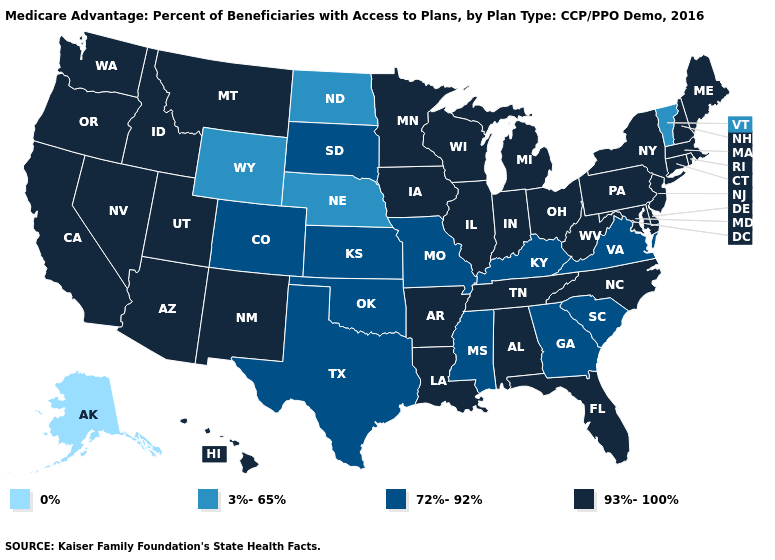Name the states that have a value in the range 93%-100%?
Quick response, please. California, Connecticut, Delaware, Florida, Hawaii, Iowa, Idaho, Illinois, Indiana, Louisiana, Massachusetts, Maryland, Maine, Michigan, Minnesota, Montana, North Carolina, New Hampshire, New Jersey, New Mexico, Nevada, New York, Ohio, Oregon, Pennsylvania, Rhode Island, Tennessee, Utah, Washington, Wisconsin, West Virginia, Alabama, Arkansas, Arizona. Does Nebraska have the highest value in the MidWest?
Quick response, please. No. Which states hav the highest value in the Northeast?
Be succinct. Connecticut, Massachusetts, Maine, New Hampshire, New Jersey, New York, Pennsylvania, Rhode Island. Does New Mexico have the lowest value in the USA?
Write a very short answer. No. Name the states that have a value in the range 93%-100%?
Be succinct. California, Connecticut, Delaware, Florida, Hawaii, Iowa, Idaho, Illinois, Indiana, Louisiana, Massachusetts, Maryland, Maine, Michigan, Minnesota, Montana, North Carolina, New Hampshire, New Jersey, New Mexico, Nevada, New York, Ohio, Oregon, Pennsylvania, Rhode Island, Tennessee, Utah, Washington, Wisconsin, West Virginia, Alabama, Arkansas, Arizona. What is the value of Rhode Island?
Concise answer only. 93%-100%. What is the highest value in the USA?
Be succinct. 93%-100%. Among the states that border Virginia , which have the lowest value?
Give a very brief answer. Kentucky. How many symbols are there in the legend?
Quick response, please. 4. What is the value of Washington?
Answer briefly. 93%-100%. Name the states that have a value in the range 72%-92%?
Concise answer only. Colorado, Georgia, Kansas, Kentucky, Missouri, Mississippi, Oklahoma, South Carolina, South Dakota, Texas, Virginia. What is the highest value in the West ?
Quick response, please. 93%-100%. Does Kansas have the lowest value in the USA?
Quick response, please. No. Name the states that have a value in the range 72%-92%?
Quick response, please. Colorado, Georgia, Kansas, Kentucky, Missouri, Mississippi, Oklahoma, South Carolina, South Dakota, Texas, Virginia. What is the value of Hawaii?
Be succinct. 93%-100%. 